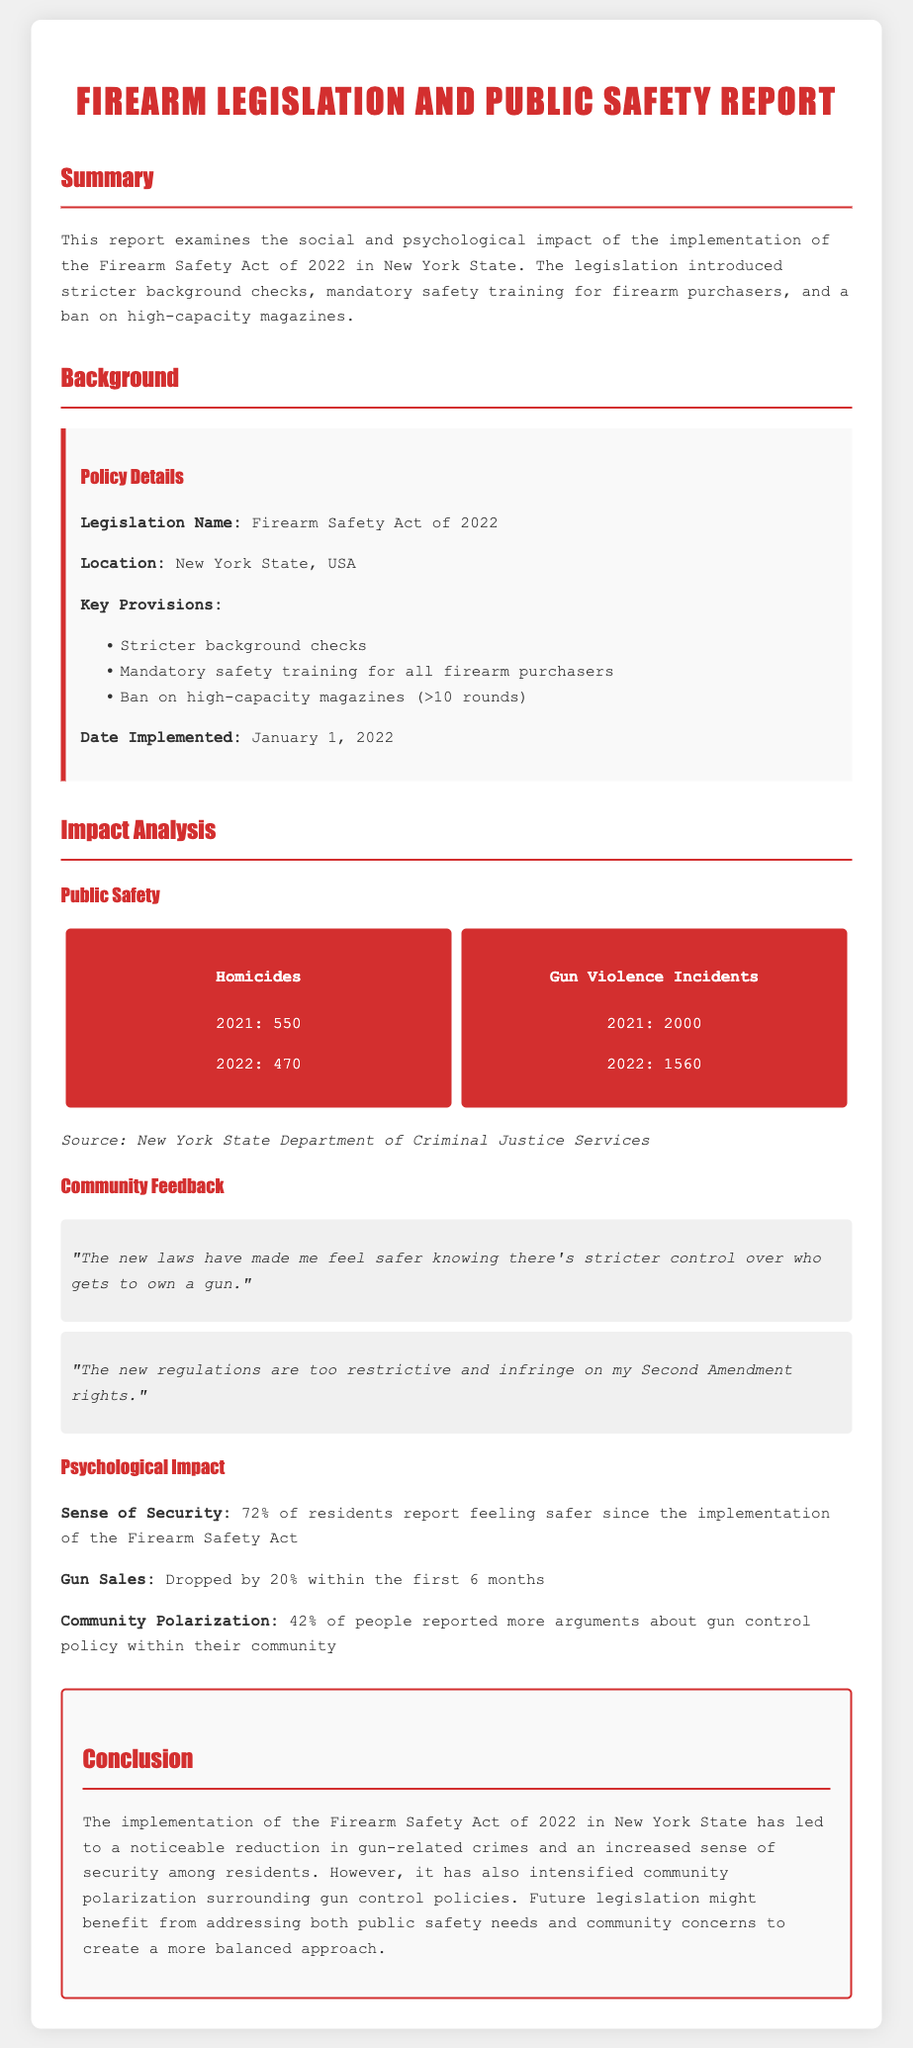What is the legislation name? The legislation name is highlighted in the policy details section of the report.
Answer: Firearm Safety Act of 2022 Where was the Firearm Safety Act implemented? The location of the legislation is provided in the policy details section.
Answer: New York State, USA What percentage of residents feel safer since the act's implementation? The percentage is found in the psychological impact section of the report.
Answer: 72% How many gun violence incidents were reported in 2022? The number can be extracted from the public safety statistics presented in the document.
Answer: 1560 What key provision involves training? The mention of mandatory training is referenced in the policy details section.
Answer: Mandatory safety training for all firearm purchasers What was the homicide count in 2021? The number can be located in the public safety statistics.
Answer: 550 What is the impact on gun sales after the act? The impact on gun sales is addressed in the psychological impact section of the report.
Answer: Dropped by 20% What community concern increased following the policy? The source of the concern is found in the psychological impact section that discusses community polarization.
Answer: Arguments about gun control policy 